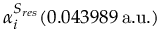Convert formula to latex. <formula><loc_0><loc_0><loc_500><loc_500>\alpha _ { i } ^ { S _ { r e s } } ( 0 . 0 4 3 9 8 9 \, a . u . )</formula> 